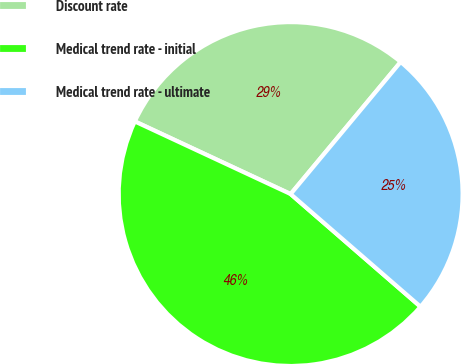<chart> <loc_0><loc_0><loc_500><loc_500><pie_chart><fcel>Discount rate<fcel>Medical trend rate - initial<fcel>Medical trend rate - ultimate<nl><fcel>29.11%<fcel>45.57%<fcel>25.32%<nl></chart> 